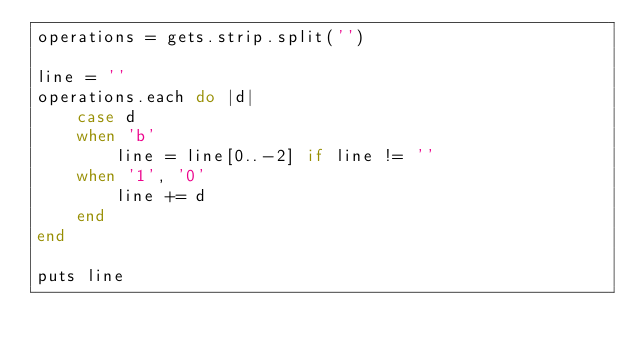Convert code to text. <code><loc_0><loc_0><loc_500><loc_500><_Ruby_>operations = gets.strip.split('')

line = ''
operations.each do |d|
	case d
	when 'b'
		line = line[0..-2] if line != ''
	when '1', '0'
		line += d
	end
end

puts line
</code> 